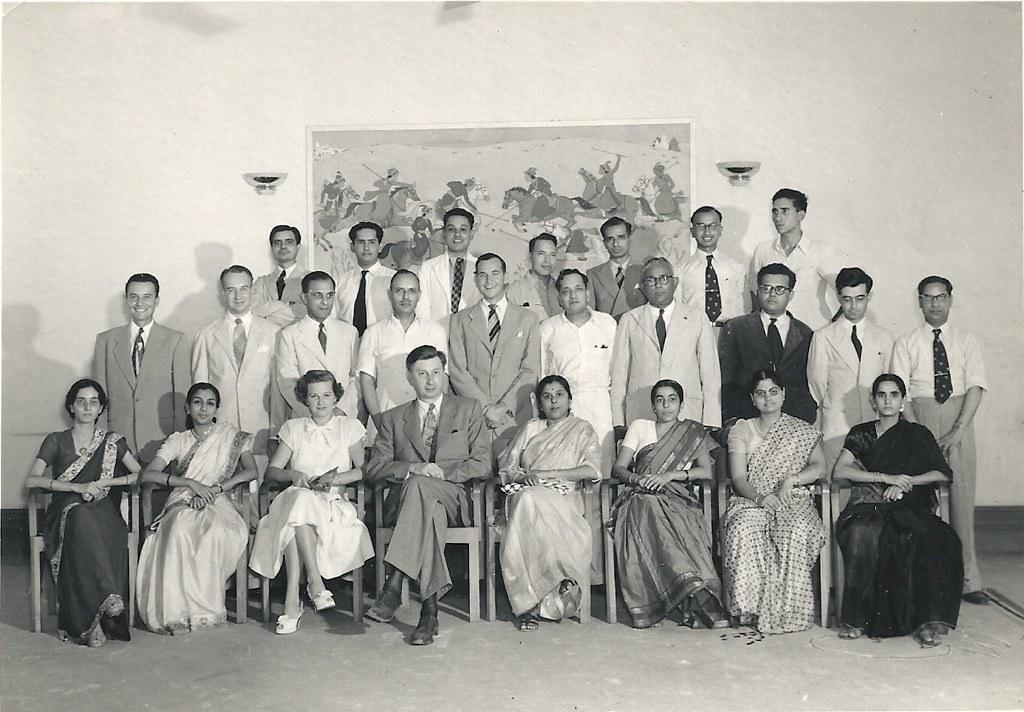Please provide a concise description of this image. This picture describes about group of people, few are seated and few are standing, in the background we can see a poster on the wall. 